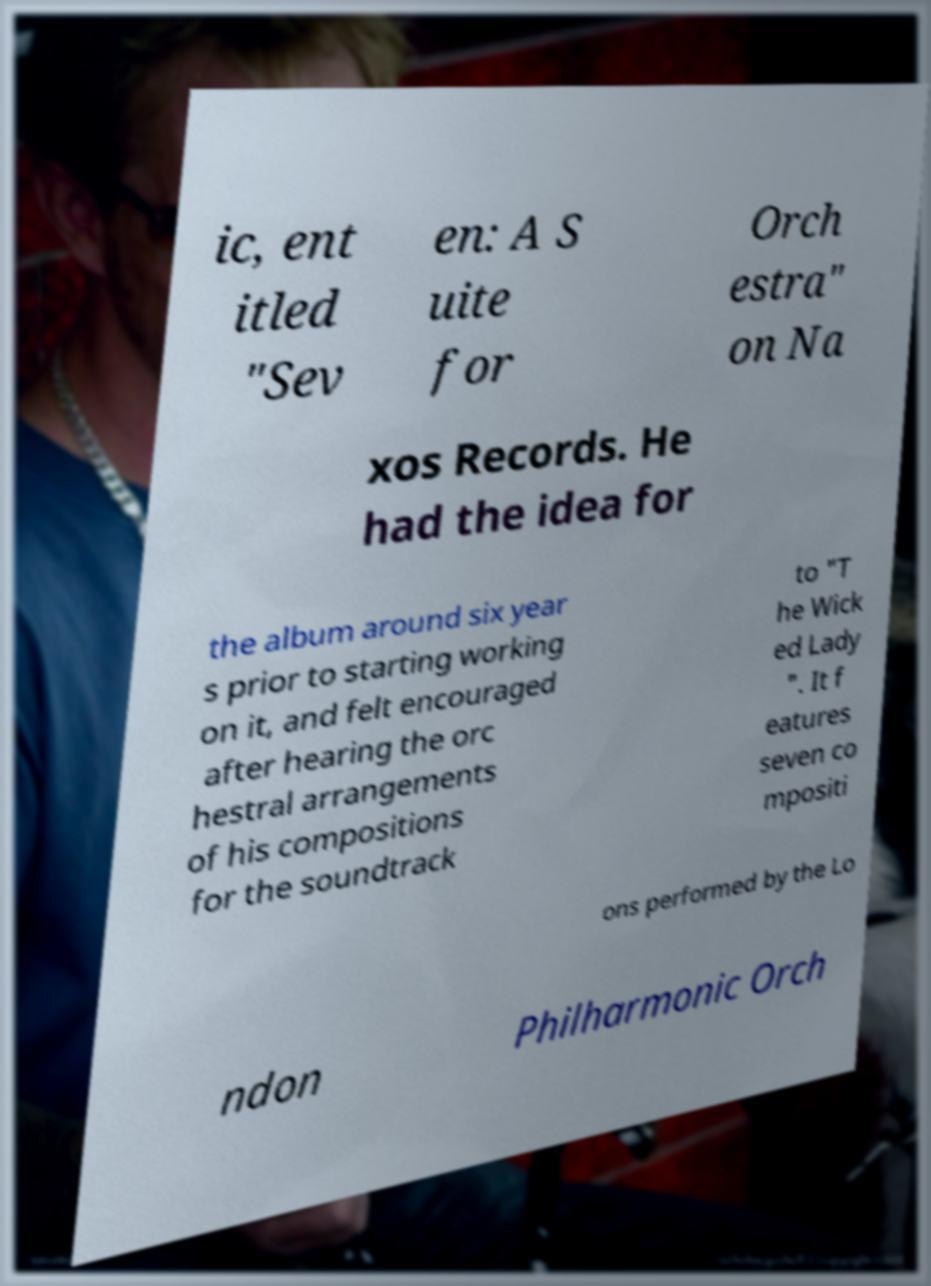Please read and relay the text visible in this image. What does it say? ic, ent itled "Sev en: A S uite for Orch estra" on Na xos Records. He had the idea for the album around six year s prior to starting working on it, and felt encouraged after hearing the orc hestral arrangements of his compositions for the soundtrack to "T he Wick ed Lady ". It f eatures seven co mpositi ons performed by the Lo ndon Philharmonic Orch 